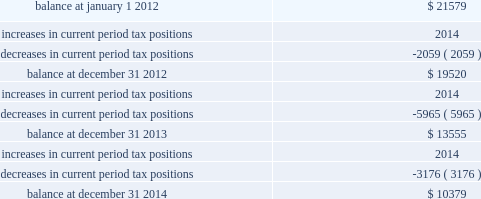Majority of the increased tax position is attributable to temporary differences .
The increase in 2014 current period tax positions related primarily to the company 2019s change in tax accounting method filed in 2008 for repair and maintenance costs on its utility plant .
The company does not anticipate material changes to its unrecognized tax benefits within the next year .
If the company sustains all of its positions at december 31 , 2014 and 2013 , an unrecognized tax benefit of $ 9444 and $ 7439 , respectively , excluding interest and penalties , would impact the company 2019s effective tax rate .
The table summarizes the changes in the company 2019s valuation allowance: .
Included in 2013 is a discrete tax benefit totaling $ 2979 associated with an entity re-organization within the company 2019s market-based operations segment that allowed for the utilization of state net operating loss carryforwards and the release of an associated valuation allowance .
Note 13 : employee benefits pension and other postretirement benefits the company maintains noncontributory defined benefit pension plans covering eligible employees of its regulated utility and shared services operations .
Benefits under the plans are based on the employee 2019s years of service and compensation .
The pension plans have been closed for all employees .
The pension plans were closed for most employees hired on or after january 1 , 2006 .
Union employees hired on or after january 1 , 2001 had their accrued benefit frozen and will be able to receive this benefit as a lump sum upon termination or retirement .
Union employees hired on or after january 1 , 2001 and non-union employees hired on or after january 1 , 2006 are provided with a 5.25% ( 5.25 % ) of base pay defined contribution plan .
The company does not participate in a multiemployer plan .
The company 2019s pension funding practice is to contribute at least the greater of the minimum amount required by the employee retirement income security act of 1974 or the normal cost .
Further , the company will consider additional contributions if needed to avoid 201cat risk 201d status and benefit restrictions under the pension protection act of 2006 .
The company may also consider increased contributions , based on other financial requirements and the plans 2019 funded position .
Pension plan assets are invested in a number of actively managed and commingled funds including equity and bond funds , fixed income securities , guaranteed interest contracts with insurance companies , real estate funds and real estate investment trusts ( 201creits 201d ) .
Pension expense in excess of the amount contributed to the pension plans is deferred by certain regulated subsidiaries pending future recovery in rates charged for utility services as contributions are made to the plans .
( see note 6 ) the company also has unfunded noncontributory supplemental non-qualified pension plans that provide additional retirement benefits to certain employees. .
By how much did the company 2019s valuation allowance decrease from the beginning of 2012 to the end of 2014? 
Computations: ((10379 - 21579) / 21579)
Answer: -0.51902. 